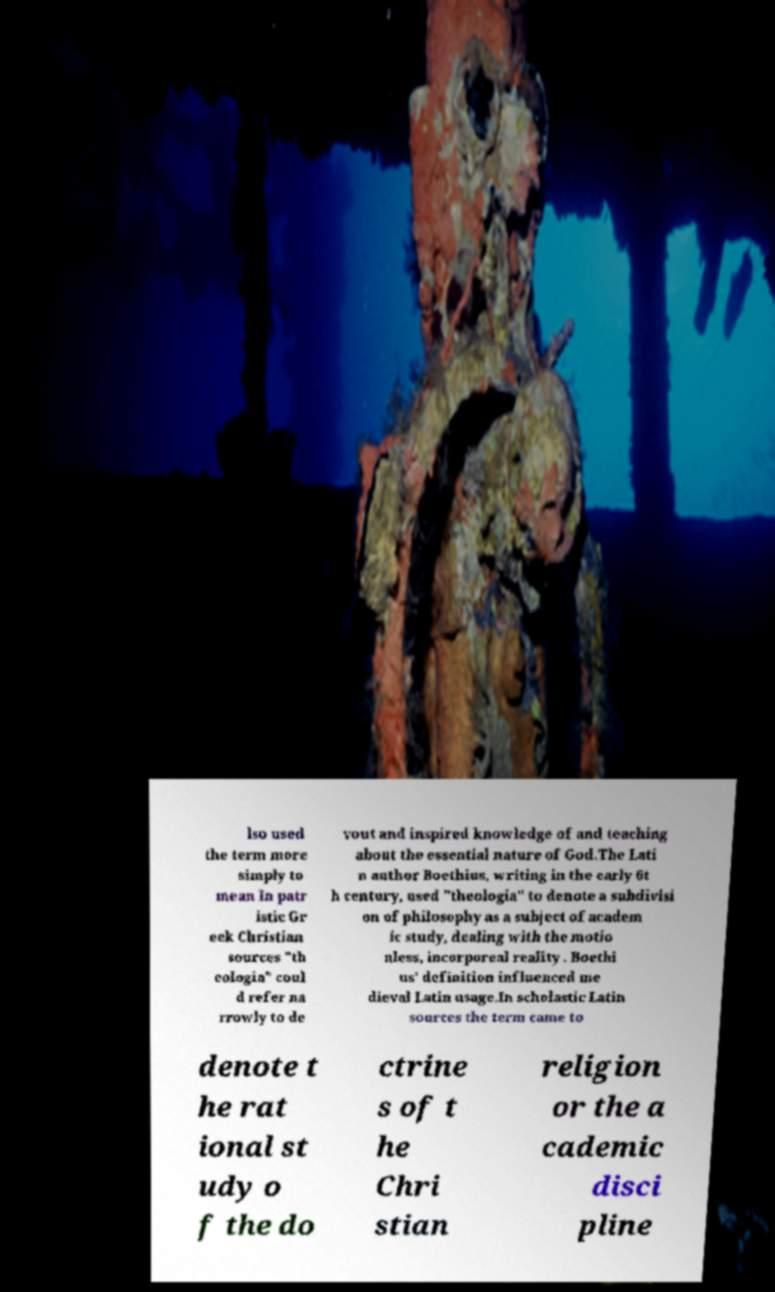For documentation purposes, I need the text within this image transcribed. Could you provide that? lso used the term more simply to mean In patr istic Gr eek Christian sources "th eologia" coul d refer na rrowly to de vout and inspired knowledge of and teaching about the essential nature of God.The Lati n author Boethius, writing in the early 6t h century, used "theologia" to denote a subdivisi on of philosophy as a subject of academ ic study, dealing with the motio nless, incorporeal reality . Boethi us' definition influenced me dieval Latin usage.In scholastic Latin sources the term came to denote t he rat ional st udy o f the do ctrine s of t he Chri stian religion or the a cademic disci pline 